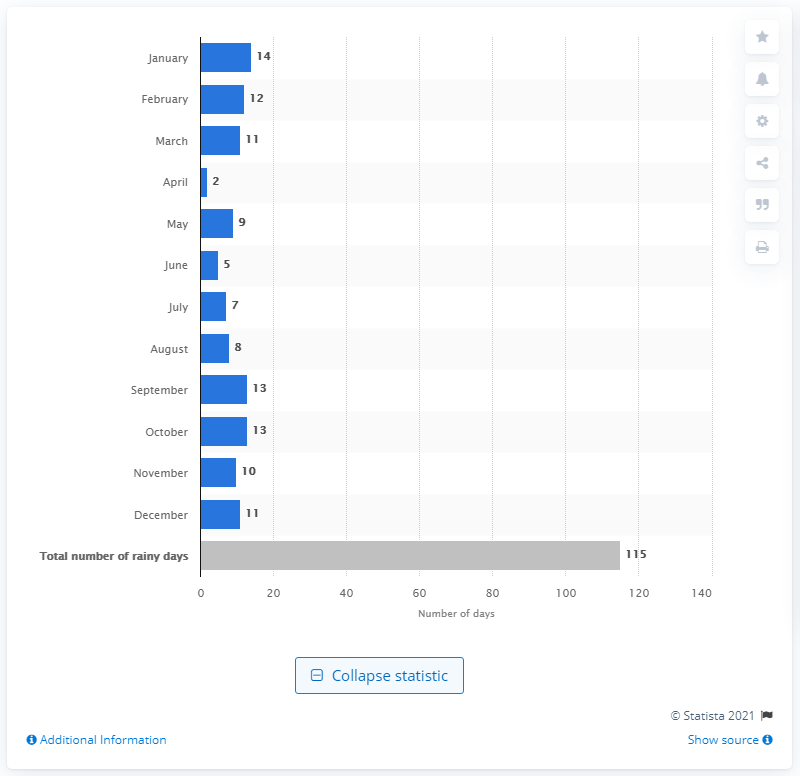Highlight a few significant elements in this photo. In April, the city of Helsinki experienced the least amount of rainfall. In January, Helsinki experienced the most rainfall days out of any month. January had 14 days of rain. 